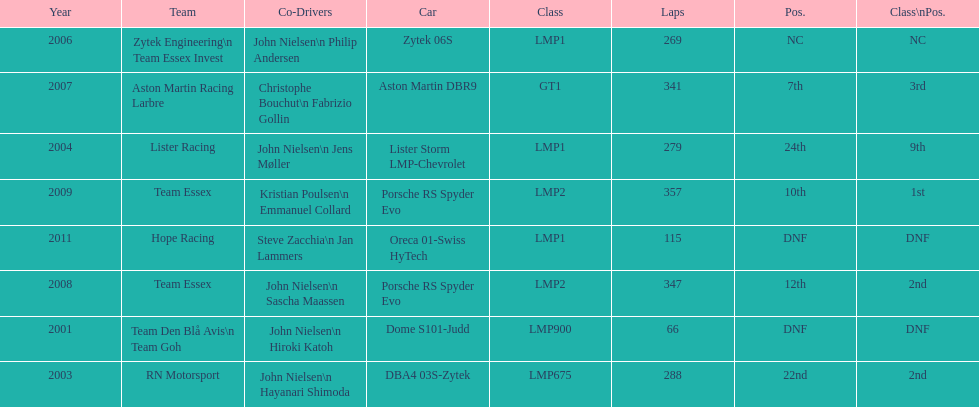What model car was the most used? Porsche RS Spyder. 